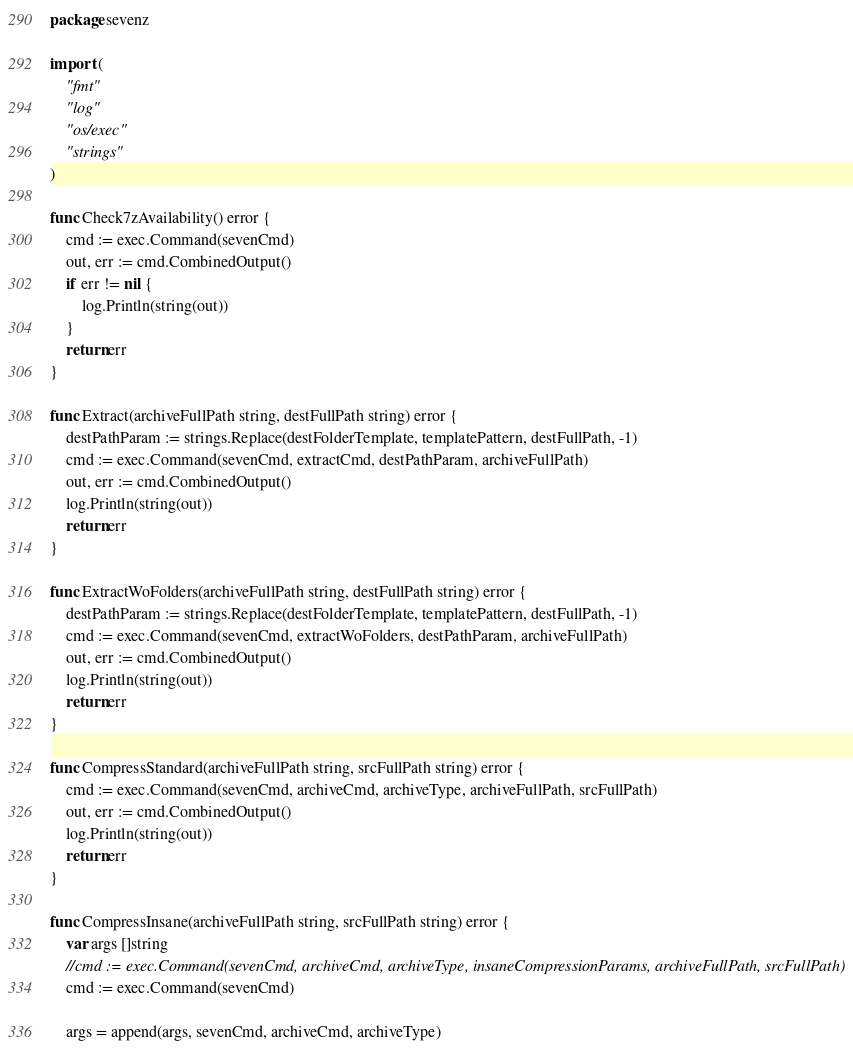<code> <loc_0><loc_0><loc_500><loc_500><_Go_>package sevenz

import (
	"fmt"
	"log"
	"os/exec"
	"strings"
)

func Check7zAvailability() error {
	cmd := exec.Command(sevenCmd)
	out, err := cmd.CombinedOutput()
	if err != nil {
		log.Println(string(out))
	}
	return err
}

func Extract(archiveFullPath string, destFullPath string) error {
	destPathParam := strings.Replace(destFolderTemplate, templatePattern, destFullPath, -1)
	cmd := exec.Command(sevenCmd, extractCmd, destPathParam, archiveFullPath)
	out, err := cmd.CombinedOutput()
	log.Println(string(out))
	return err
}

func ExtractWoFolders(archiveFullPath string, destFullPath string) error {
	destPathParam := strings.Replace(destFolderTemplate, templatePattern, destFullPath, -1)
	cmd := exec.Command(sevenCmd, extractWoFolders, destPathParam, archiveFullPath)
	out, err := cmd.CombinedOutput()
	log.Println(string(out))
	return err
}

func CompressStandard(archiveFullPath string, srcFullPath string) error {
	cmd := exec.Command(sevenCmd, archiveCmd, archiveType, archiveFullPath, srcFullPath)
	out, err := cmd.CombinedOutput()
	log.Println(string(out))
	return err
}

func CompressInsane(archiveFullPath string, srcFullPath string) error {
	var args []string
	//cmd := exec.Command(sevenCmd, archiveCmd, archiveType, insaneCompressionParams, archiveFullPath, srcFullPath)
	cmd := exec.Command(sevenCmd)

	args = append(args, sevenCmd, archiveCmd, archiveType)</code> 